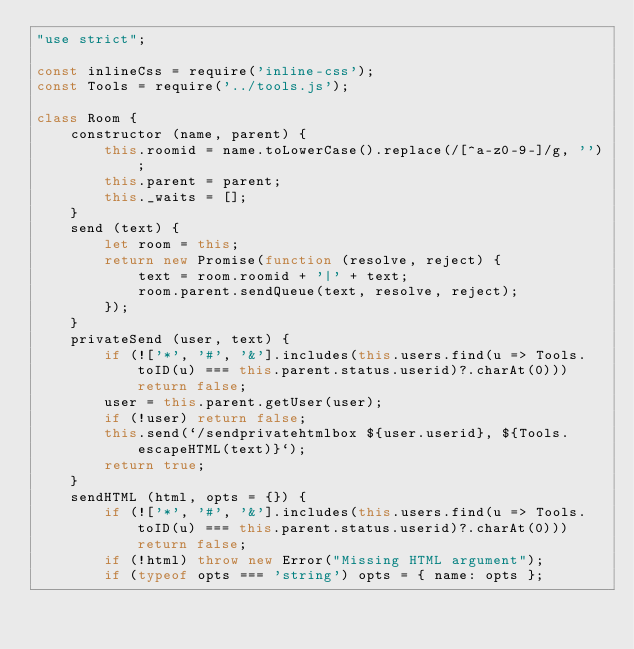<code> <loc_0><loc_0><loc_500><loc_500><_JavaScript_>"use strict";

const inlineCss = require('inline-css');
const Tools = require('../tools.js');

class Room {
	constructor (name, parent) {
		this.roomid = name.toLowerCase().replace(/[^a-z0-9-]/g, '');
		this.parent = parent;
		this._waits = [];
	}
	send (text) {
		let room = this;
		return new Promise(function (resolve, reject) {
			text = room.roomid + '|' + text;
			room.parent.sendQueue(text, resolve, reject);
		});
	}
	privateSend (user, text) {
		if (!['*', '#', '&'].includes(this.users.find(u => Tools.toID(u) === this.parent.status.userid)?.charAt(0))) return false;
		user = this.parent.getUser(user);
		if (!user) return false;
		this.send(`/sendprivatehtmlbox ${user.userid}, ${Tools.escapeHTML(text)}`);
		return true;
	}
	sendHTML (html, opts = {}) {
		if (!['*', '#', '&'].includes(this.users.find(u => Tools.toID(u) === this.parent.status.userid)?.charAt(0))) return false;
		if (!html) throw new Error("Missing HTML argument");
		if (typeof opts === 'string') opts = { name: opts };</code> 